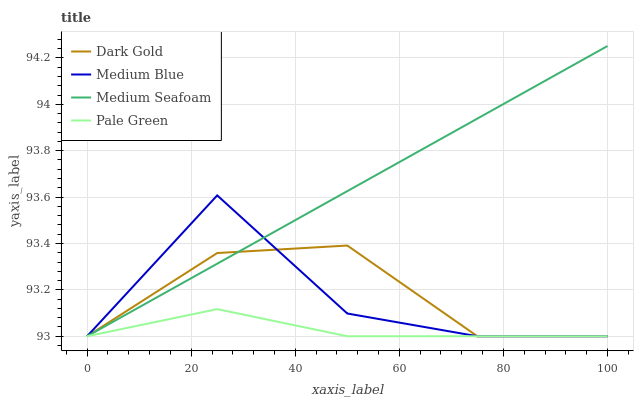Does Pale Green have the minimum area under the curve?
Answer yes or no. Yes. Does Medium Seafoam have the maximum area under the curve?
Answer yes or no. Yes. Does Medium Blue have the minimum area under the curve?
Answer yes or no. No. Does Medium Blue have the maximum area under the curve?
Answer yes or no. No. Is Medium Seafoam the smoothest?
Answer yes or no. Yes. Is Medium Blue the roughest?
Answer yes or no. Yes. Is Medium Blue the smoothest?
Answer yes or no. No. Is Medium Seafoam the roughest?
Answer yes or no. No. Does Pale Green have the lowest value?
Answer yes or no. Yes. Does Medium Seafoam have the highest value?
Answer yes or no. Yes. Does Medium Blue have the highest value?
Answer yes or no. No. Does Dark Gold intersect Medium Seafoam?
Answer yes or no. Yes. Is Dark Gold less than Medium Seafoam?
Answer yes or no. No. Is Dark Gold greater than Medium Seafoam?
Answer yes or no. No. 